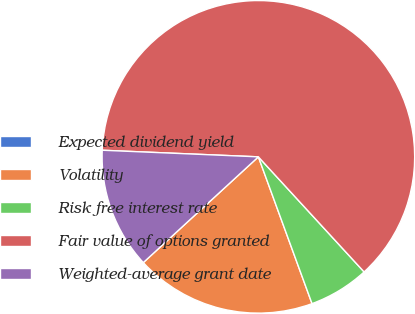Convert chart. <chart><loc_0><loc_0><loc_500><loc_500><pie_chart><fcel>Expected dividend yield<fcel>Volatility<fcel>Risk free interest rate<fcel>Fair value of options granted<fcel>Weighted-average grant date<nl><fcel>0.0%<fcel>18.75%<fcel>6.25%<fcel>62.5%<fcel>12.5%<nl></chart> 